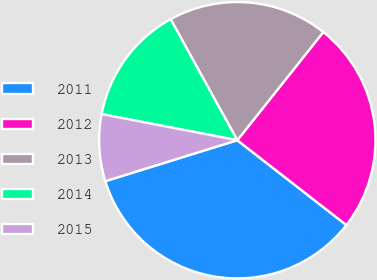<chart> <loc_0><loc_0><loc_500><loc_500><pie_chart><fcel>2011<fcel>2012<fcel>2013<fcel>2014<fcel>2015<nl><fcel>34.69%<fcel>24.83%<fcel>18.71%<fcel>13.95%<fcel>7.82%<nl></chart> 